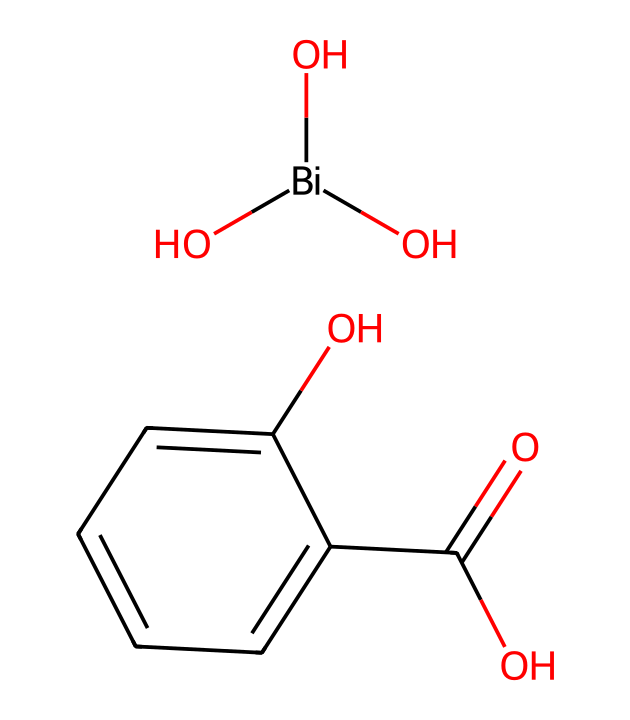What is the molecular formula of bismuth subsalicylate? The SMILES representation can be analyzed to deduce the number of each type of atom present. From the structure, there are 2 oxygen atoms from the bismuth part, 2 oxygen atoms in the salicylic acid part, and 9 carbon atoms total, leading us to the formula C9H9BiO5.
Answer: C9H9BiO5 How many hydroxyl groups are present in the molecule? By examining the structure, we can identify the hydroxyl groups (OH). There are two OH groups present in this chemical.
Answer: 2 What is the coordination number of bismuth in this compound? In this structure, bismuth is connected to three oxygen atoms (two from hydroxyl groups, one from the carboxyl group), indicating its coordination number is three.
Answer: 3 Which type of bonding is mostly involved in this compound given the presence of oxygen? Analyzing the structure reveals that there are significant covalent bonds formed between bismuth and oxygen atoms, as well as other atoms in this molecule, characteristic of antidiarrheal medications.
Answer: Covalent Does the chemical structure indicate any acidic characteristics? Yes, the presence of the carboxylic acid functional group (-COOH) suggests that this chemical has acidic properties due to its ability to donate protons.
Answer: Yes 